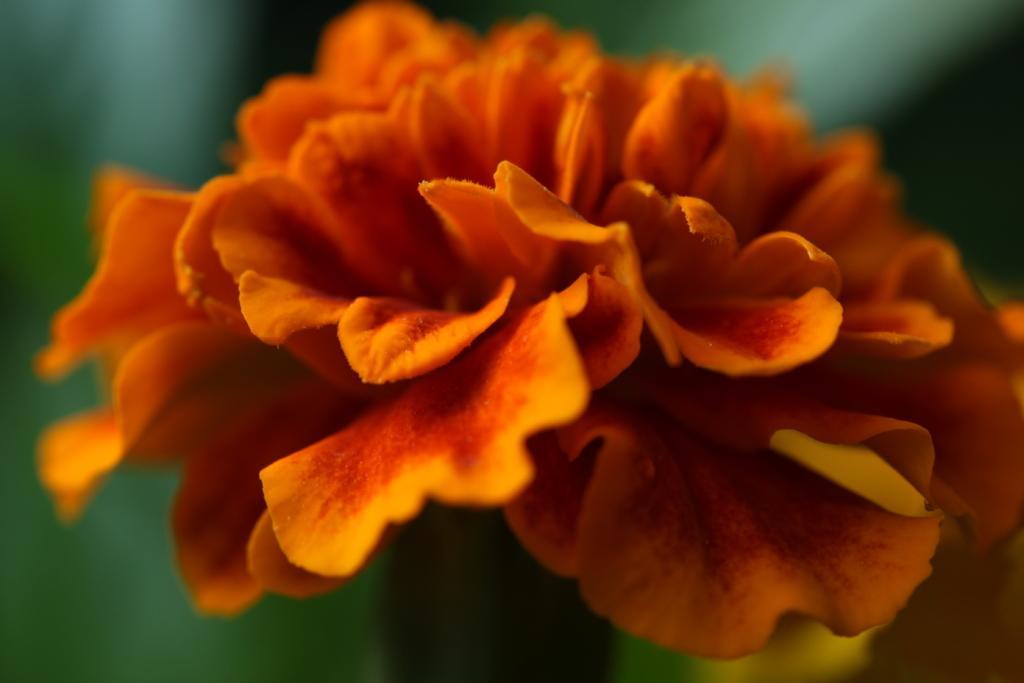Describe this image in one or two sentences. In this picture I can see a flower and I can see blurry background. 